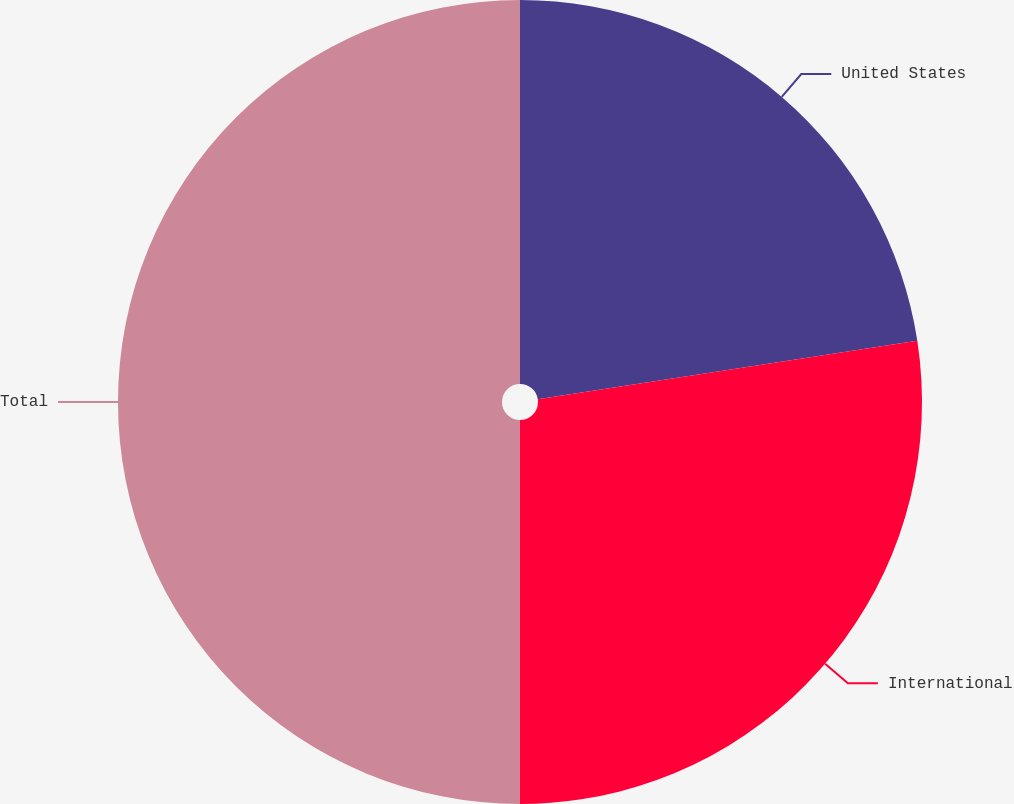Convert chart to OTSL. <chart><loc_0><loc_0><loc_500><loc_500><pie_chart><fcel>United States<fcel>International<fcel>Total<nl><fcel>22.57%<fcel>27.43%<fcel>50.0%<nl></chart> 